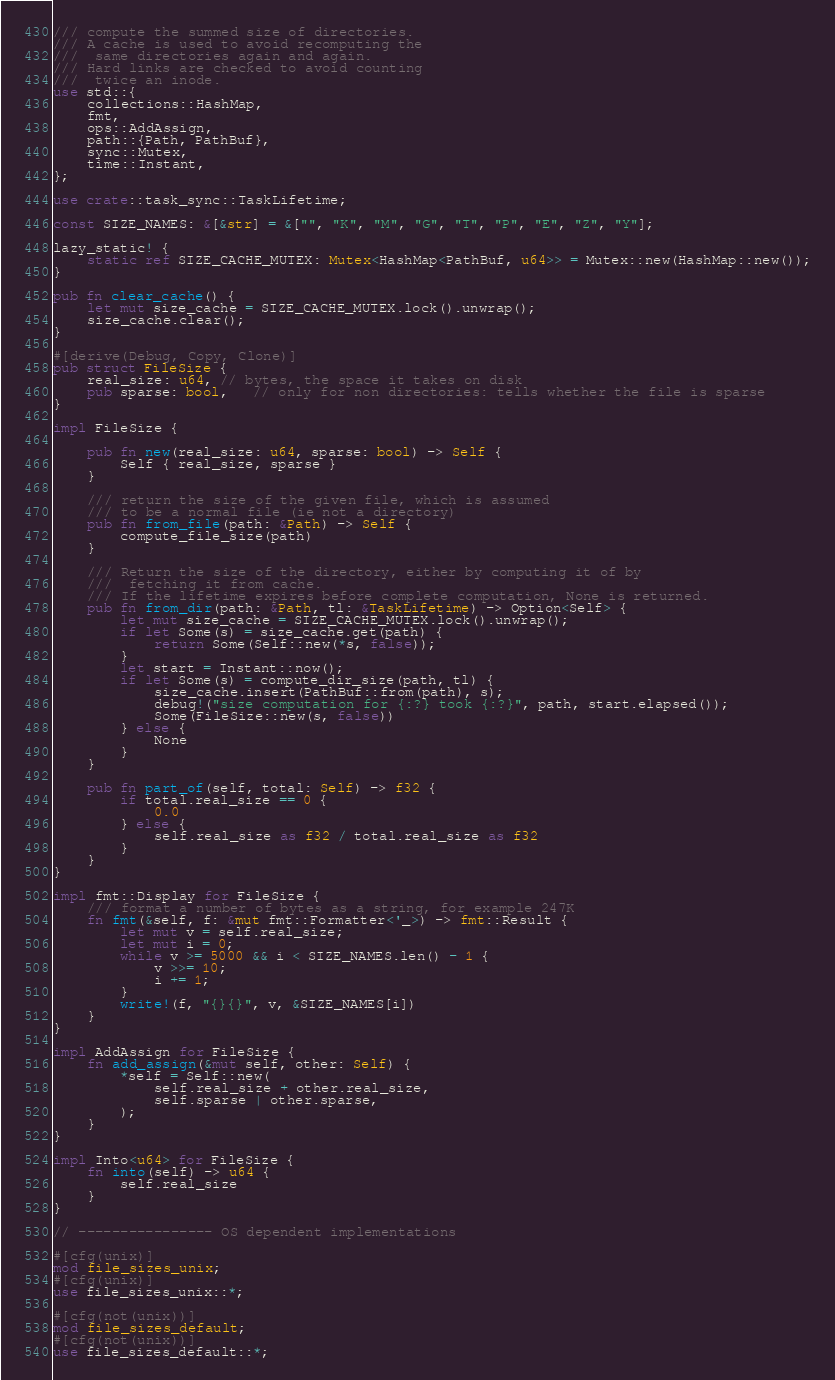Convert code to text. <code><loc_0><loc_0><loc_500><loc_500><_Rust_>/// compute the summed size of directories.
/// A cache is used to avoid recomputing the
///  same directories again and again.
/// Hard links are checked to avoid counting
///  twice an inode.
use std::{
    collections::HashMap,
    fmt,
    ops::AddAssign,
    path::{Path, PathBuf},
    sync::Mutex,
    time::Instant,
};

use crate::task_sync::TaskLifetime;

const SIZE_NAMES: &[&str] = &["", "K", "M", "G", "T", "P", "E", "Z", "Y"];

lazy_static! {
    static ref SIZE_CACHE_MUTEX: Mutex<HashMap<PathBuf, u64>> = Mutex::new(HashMap::new());
}

pub fn clear_cache() {
    let mut size_cache = SIZE_CACHE_MUTEX.lock().unwrap();
    size_cache.clear();
}

#[derive(Debug, Copy, Clone)]
pub struct FileSize {
    real_size: u64, // bytes, the space it takes on disk
    pub sparse: bool,   // only for non directories: tells whether the file is sparse
}

impl FileSize {

    pub fn new(real_size: u64, sparse: bool) -> Self {
        Self { real_size, sparse }
    }

    /// return the size of the given file, which is assumed
    /// to be a normal file (ie not a directory)
    pub fn from_file(path: &Path) -> Self {
        compute_file_size(path)
    }

    /// Return the size of the directory, either by computing it of by
    ///  fetching it from cache.
    /// If the lifetime expires before complete computation, None is returned.
    pub fn from_dir(path: &Path, tl: &TaskLifetime) -> Option<Self> {
        let mut size_cache = SIZE_CACHE_MUTEX.lock().unwrap();
        if let Some(s) = size_cache.get(path) {
            return Some(Self::new(*s, false));
        }
        let start = Instant::now();
        if let Some(s) = compute_dir_size(path, tl) {
            size_cache.insert(PathBuf::from(path), s);
            debug!("size computation for {:?} took {:?}", path, start.elapsed());
            Some(FileSize::new(s, false))
        } else {
            None
        }
    }

    pub fn part_of(self, total: Self) -> f32 {
        if total.real_size == 0 {
            0.0
        } else {
            self.real_size as f32 / total.real_size as f32
        }
    }
}

impl fmt::Display for FileSize {
    /// format a number of bytes as a string, for example 247K
    fn fmt(&self, f: &mut fmt::Formatter<'_>) -> fmt::Result {
        let mut v = self.real_size;
        let mut i = 0;
        while v >= 5000 && i < SIZE_NAMES.len() - 1 {
            v >>= 10;
            i += 1;
        }
        write!(f, "{}{}", v, &SIZE_NAMES[i])
    }
}

impl AddAssign for FileSize {
    fn add_assign(&mut self, other: Self) {
        *self = Self::new(
            self.real_size + other.real_size,
            self.sparse | other.sparse,
        );
    }
}

impl Into<u64> for FileSize {
    fn into(self) -> u64 {
        self.real_size
    }
}

// ---------------- OS dependent implementations

#[cfg(unix)]
mod file_sizes_unix;
#[cfg(unix)]
use file_sizes_unix::*;

#[cfg(not(unix))]
mod file_sizes_default;
#[cfg(not(unix))]
use file_sizes_default::*;

</code> 